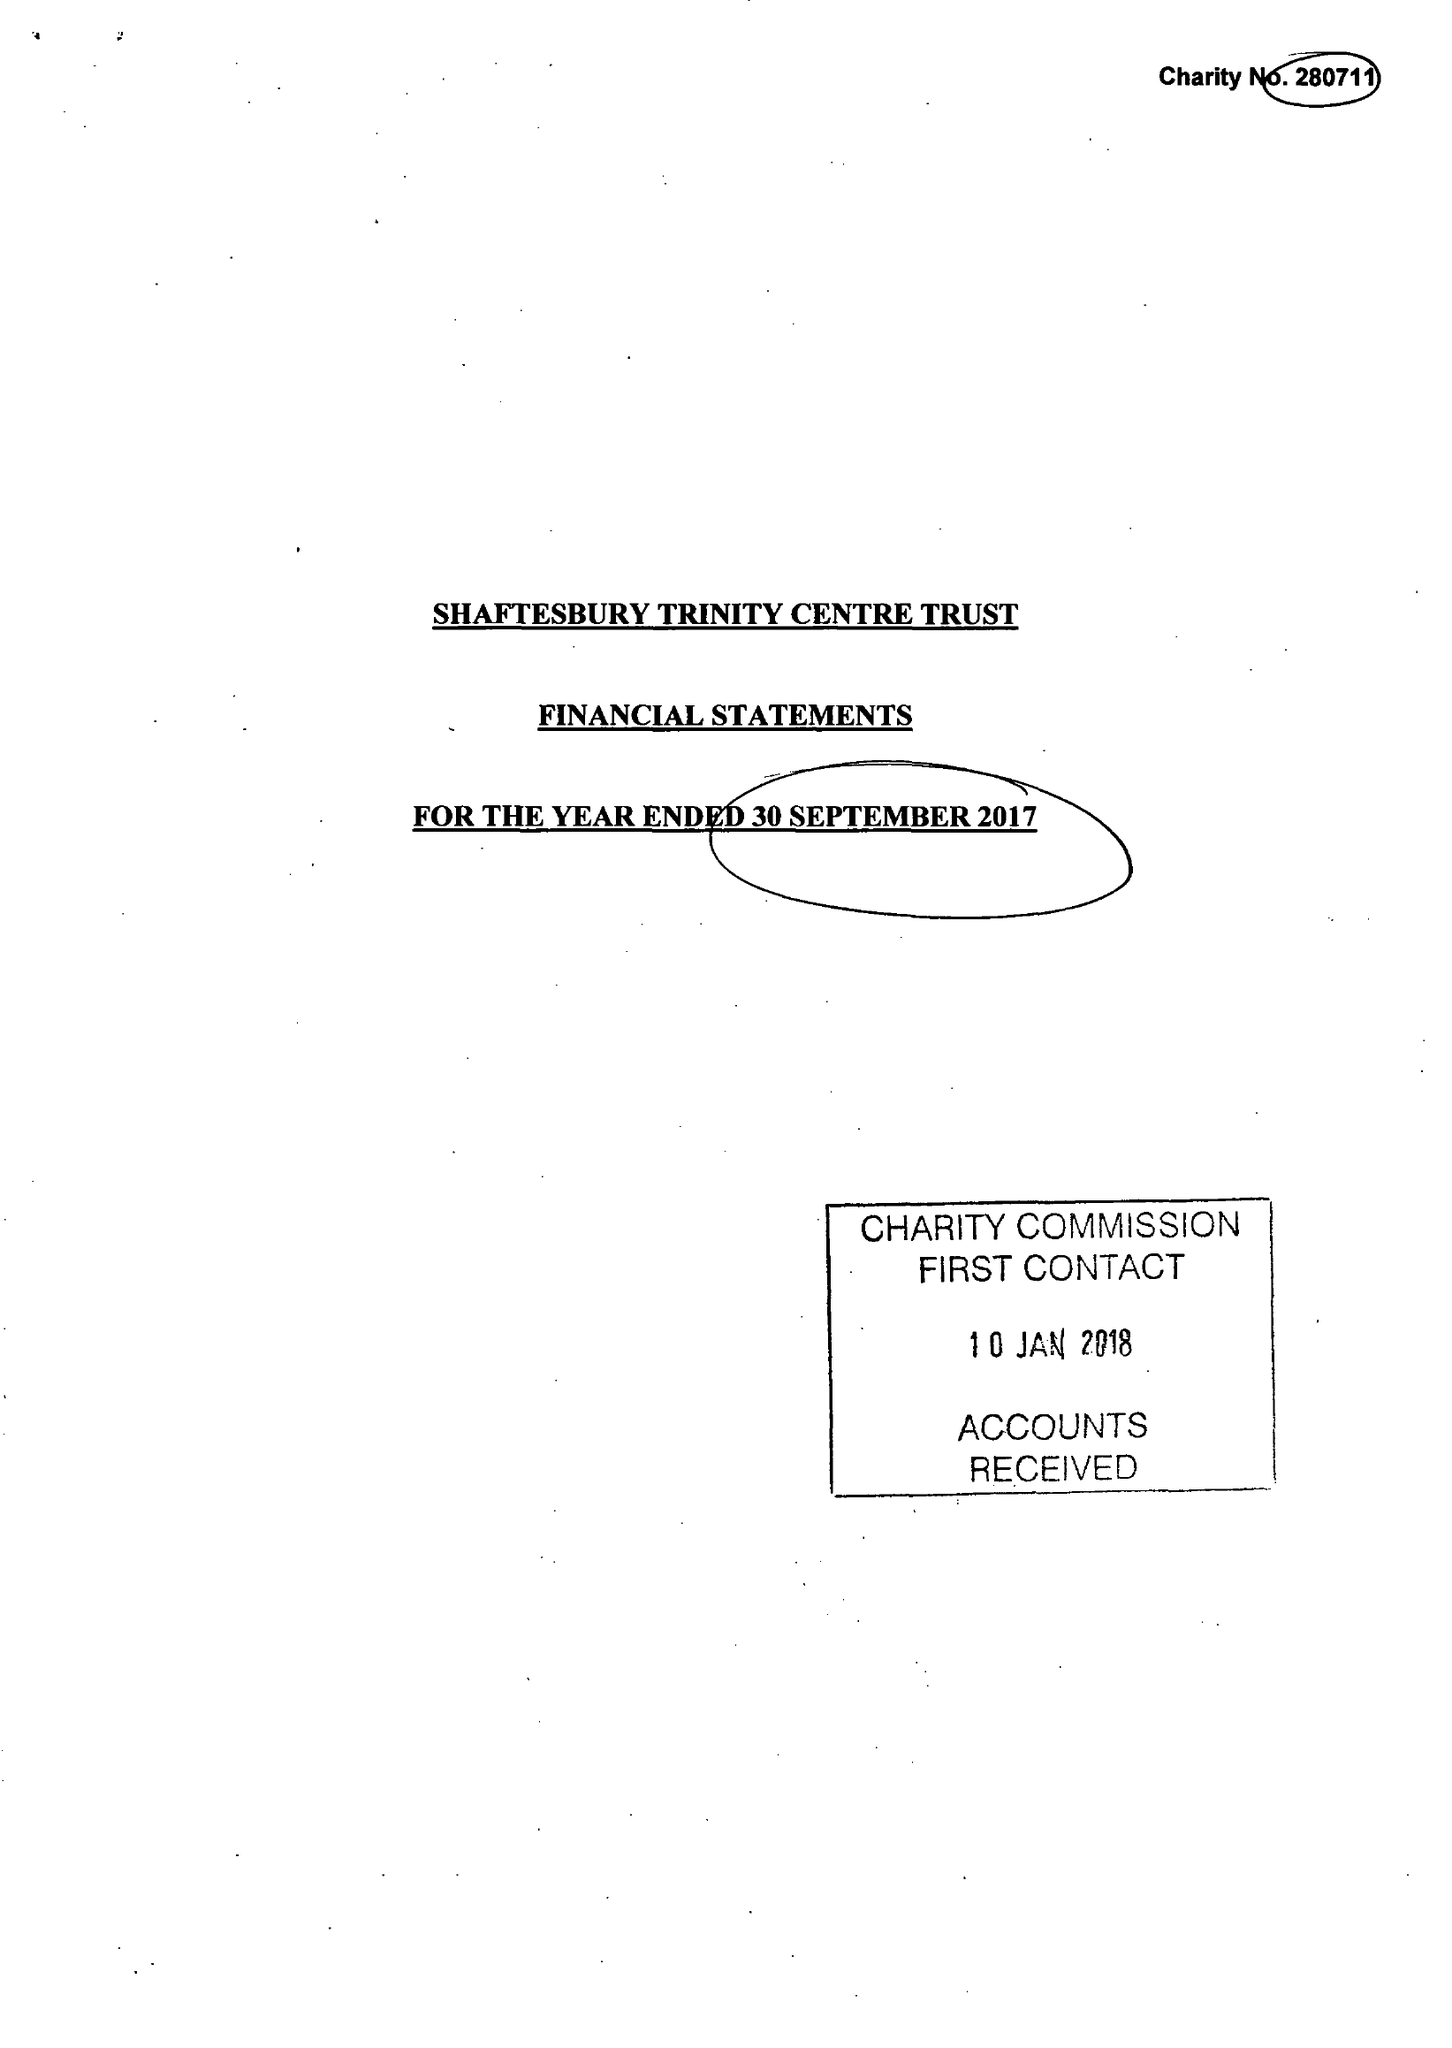What is the value for the charity_name?
Answer the question using a single word or phrase. Shaftesbury Trinity Centre Trust 